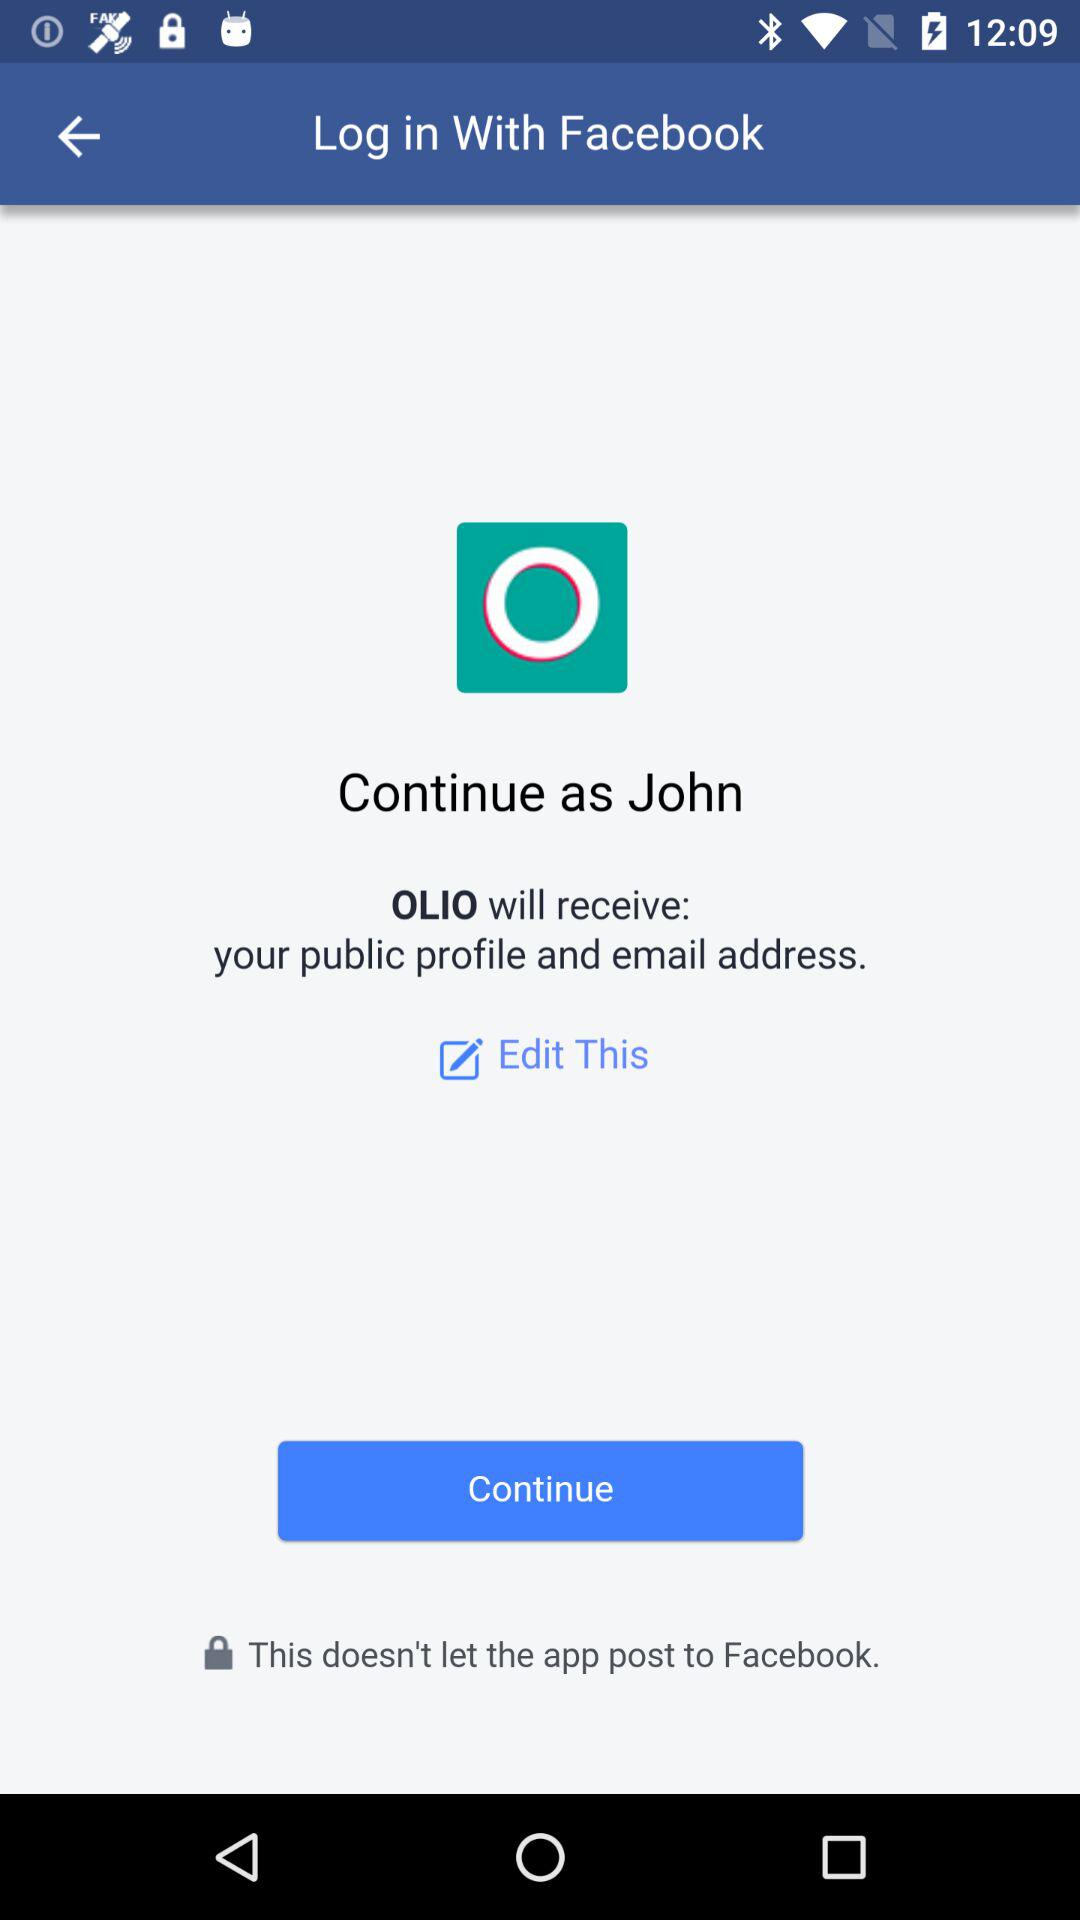Did John edit this?
When the provided information is insufficient, respond with <no answer>. <no answer> 